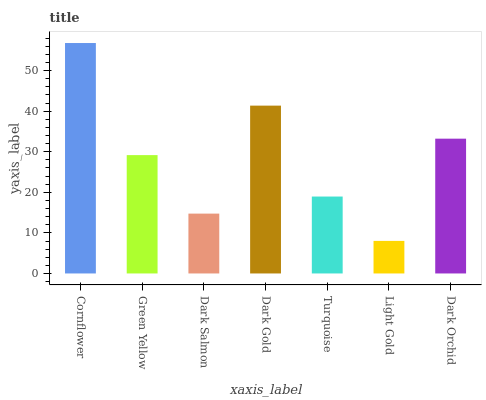Is Light Gold the minimum?
Answer yes or no. Yes. Is Cornflower the maximum?
Answer yes or no. Yes. Is Green Yellow the minimum?
Answer yes or no. No. Is Green Yellow the maximum?
Answer yes or no. No. Is Cornflower greater than Green Yellow?
Answer yes or no. Yes. Is Green Yellow less than Cornflower?
Answer yes or no. Yes. Is Green Yellow greater than Cornflower?
Answer yes or no. No. Is Cornflower less than Green Yellow?
Answer yes or no. No. Is Green Yellow the high median?
Answer yes or no. Yes. Is Green Yellow the low median?
Answer yes or no. Yes. Is Turquoise the high median?
Answer yes or no. No. Is Dark Salmon the low median?
Answer yes or no. No. 